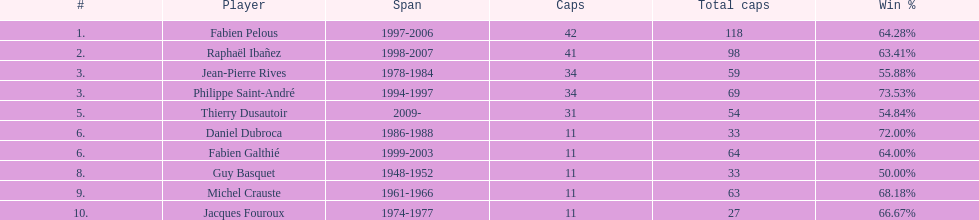Would you mind parsing the complete table? {'header': ['#', 'Player', 'Span', 'Caps', 'Total caps', 'Win\xa0%'], 'rows': [['1.', 'Fabien Pelous', '1997-2006', '42', '118', '64.28%'], ['2.', 'Raphaël Ibañez', '1998-2007', '41', '98', '63.41%'], ['3.', 'Jean-Pierre Rives', '1978-1984', '34', '59', '55.88%'], ['3.', 'Philippe Saint-André', '1994-1997', '34', '69', '73.53%'], ['5.', 'Thierry Dusautoir', '2009-', '31', '54', '54.84%'], ['6.', 'Daniel Dubroca', '1986-1988', '11', '33', '72.00%'], ['6.', 'Fabien Galthié', '1999-2003', '11', '64', '64.00%'], ['8.', 'Guy Basquet', '1948-1952', '11', '33', '50.00%'], ['9.', 'Michel Crauste', '1961-1966', '11', '63', '68.18%'], ['10.', 'Jacques Fouroux', '1974-1977', '11', '27', '66.67%']]} For how long did michel crauste hold the captain position? 1961-1966. 